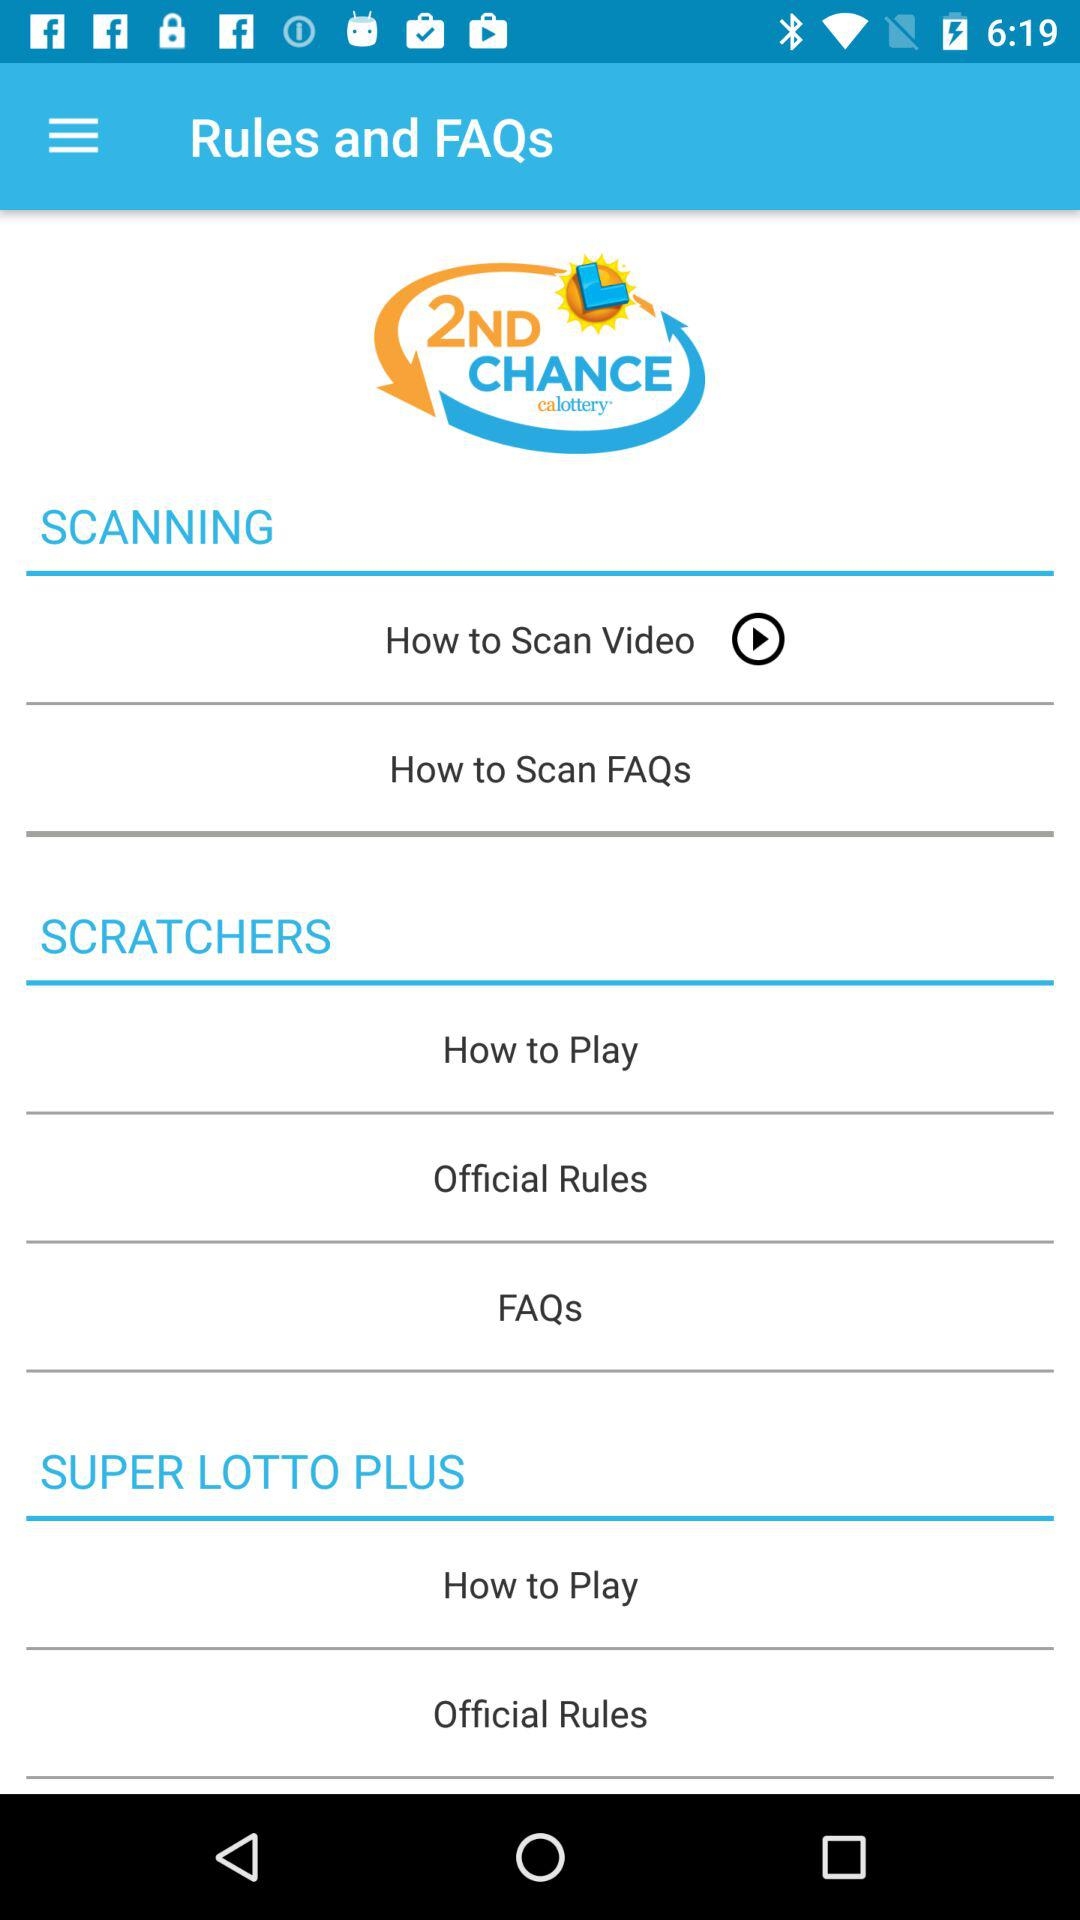What is the application name? The application name is "2ND CHANCE calottery". 